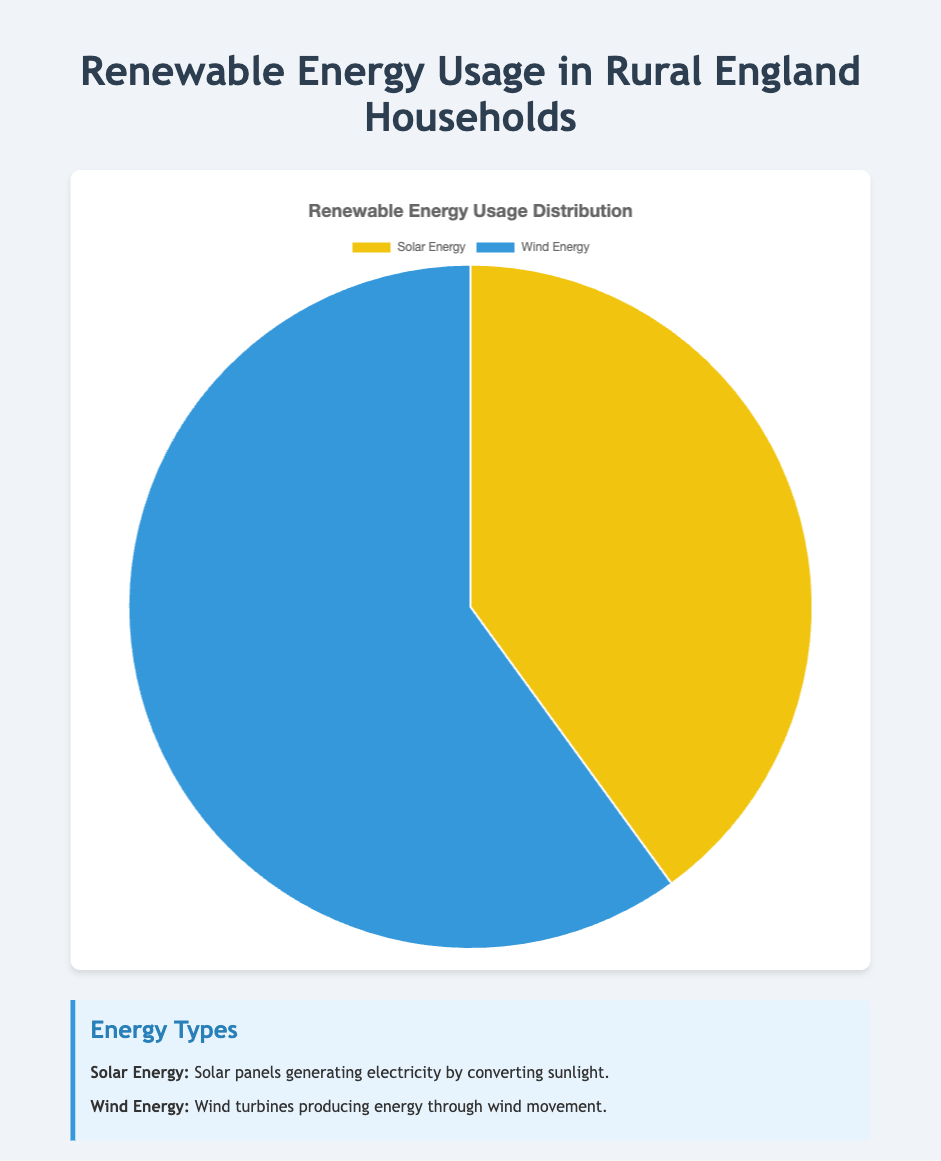What's the percentage of households using Solar Energy? The pie chart shows the distribution of renewable energy usage. The segment representing Solar Energy is labeled with its percentage.
Answer: 40% How many more households use Wind Energy compared to Solar Energy? The pie chart indicates the number of households for each type of renewable energy. Subtract the number of Solar Energy households (800) from the number of Wind Energy households (1200): 1200 - 800 = 400
Answer: 400 What is the total number of households using renewable energy? Add the number of households using Solar Energy (800) and the number of households using Wind Energy (1200): 800 + 1200 = 2000
Answer: 2000 Which renewable energy source is used by a greater percentage of households? Compare the percentages given in the pie chart for Solar Energy (40%) and Wind Energy (60%). Wind Energy has the larger percentage.
Answer: Wind Energy What percentage of the households use either Solar Energy or Wind Energy? Since Solar Energy and Wind Energy are the only types of renewable energy shown, their combined percentage is 100%.
Answer: 100% What is the ratio of households using Wind Energy to those using Solar Energy? Compare the number of households using Wind Energy (1200) to the number of households using Solar Energy (800). The ratio is 1200:800, which simplifies to 3:2.
Answer: 3:2 What is the color representing Wind Energy in the pie chart? Observe the color legend or the pie chart itself, where Wind Energy is represented by the blue segment.
Answer: Blue If the number of households using Solar Energy increased by 20%, what would be the new percentage of households using Solar Energy? A 20% increase in households using Solar Energy means adding 20% of 800 to the current number: 0.20 * 800 = 160. Therefore, the new number of households is 800 + 160 = 960. Calculate the new percentage: (960 / (960 + 1200)) * 100. First, find the total number of households: 960 + 1200 = 2160, then: (960 / 2160) * 100 ≈ 44.44%
Answer: 44.44% What proportion of the slice representing Solar Energy does the slice representing Wind Energy have? The proportion can be determined by dividing the percentage of Wind Energy by the percentage of Solar Energy: 60% / 40% = 1.5. This means Wind Energy's slice is 1.5 times larger than Solar Energy's slice.
Answer: 1.5 times If 100 households switch from Wind Energy to Solar Energy, what would be the new percentages for both energy types? Subtract 100 from Wind Energy households (1200 - 100 = 1100) and add 100 to Solar Energy households (800 + 100 = 900). Calculate the new percentages: For Solar Energy: (900 / (900 + 1100)) * 100 = 45%, and for Wind Energy: (1100 / (900 + 1100)) * 100 = 55%.
Answer: Solar Energy: 45%, Wind Energy: 55% 